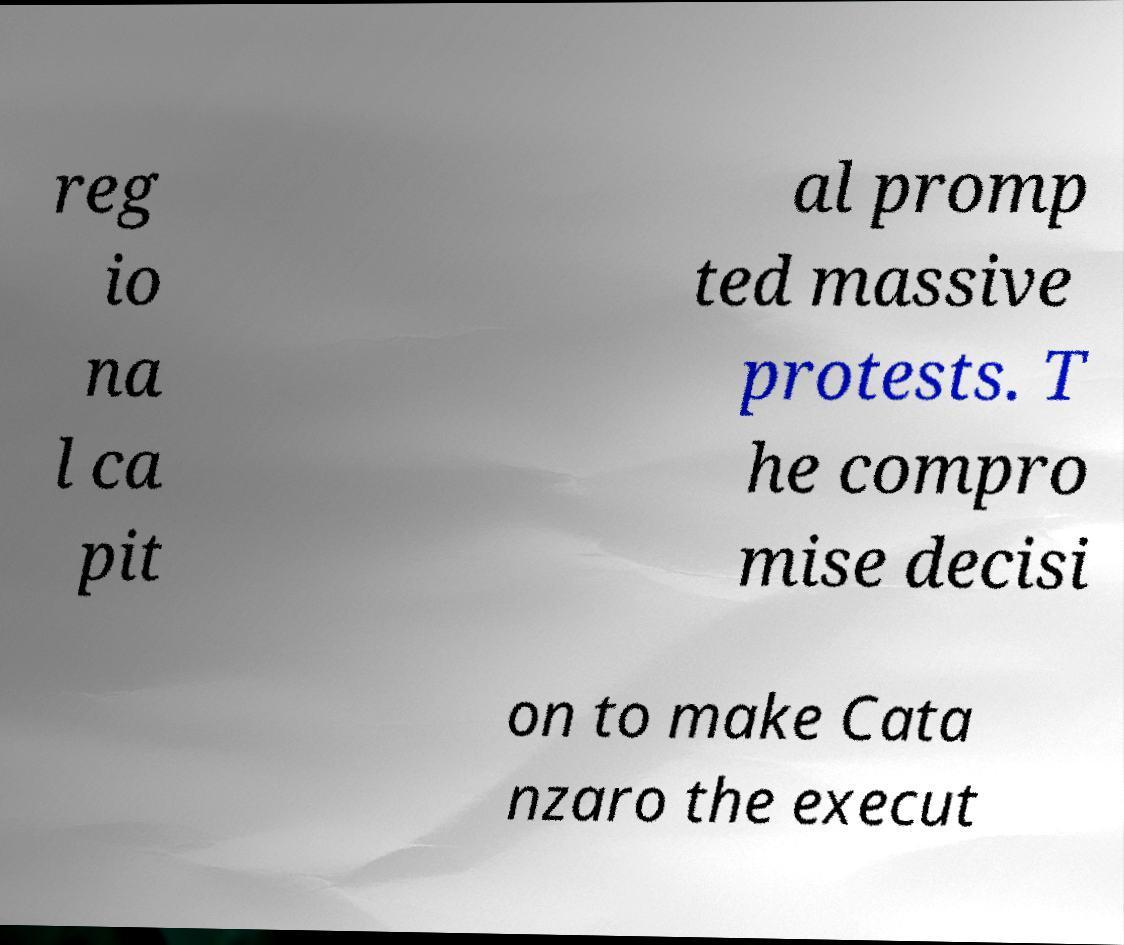There's text embedded in this image that I need extracted. Can you transcribe it verbatim? reg io na l ca pit al promp ted massive protests. T he compro mise decisi on to make Cata nzaro the execut 